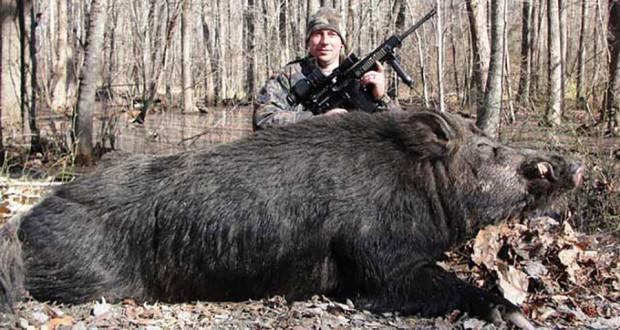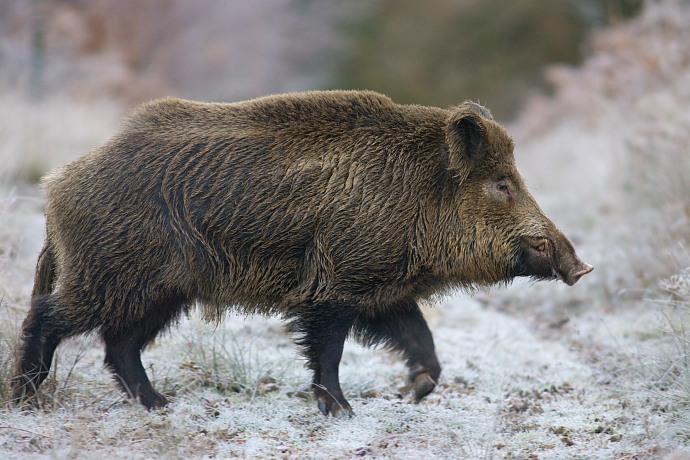The first image is the image on the left, the second image is the image on the right. Examine the images to the left and right. Is the description "The left image shows only an adult boar, which is facing leftward." accurate? Answer yes or no. No. The first image is the image on the left, the second image is the image on the right. Examine the images to the left and right. Is the description "The hog on the right image is standing and facing right" accurate? Answer yes or no. Yes. 